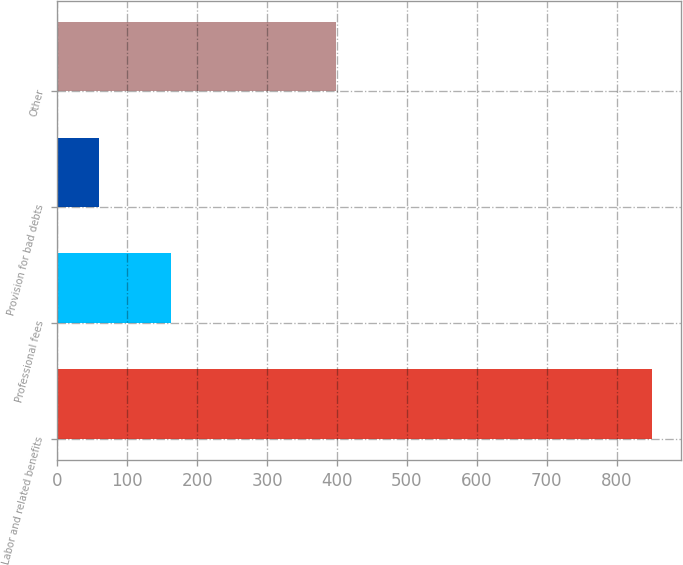Convert chart to OTSL. <chart><loc_0><loc_0><loc_500><loc_500><bar_chart><fcel>Labor and related benefits<fcel>Professional fees<fcel>Provision for bad debts<fcel>Other<nl><fcel>850<fcel>163<fcel>60<fcel>399<nl></chart> 